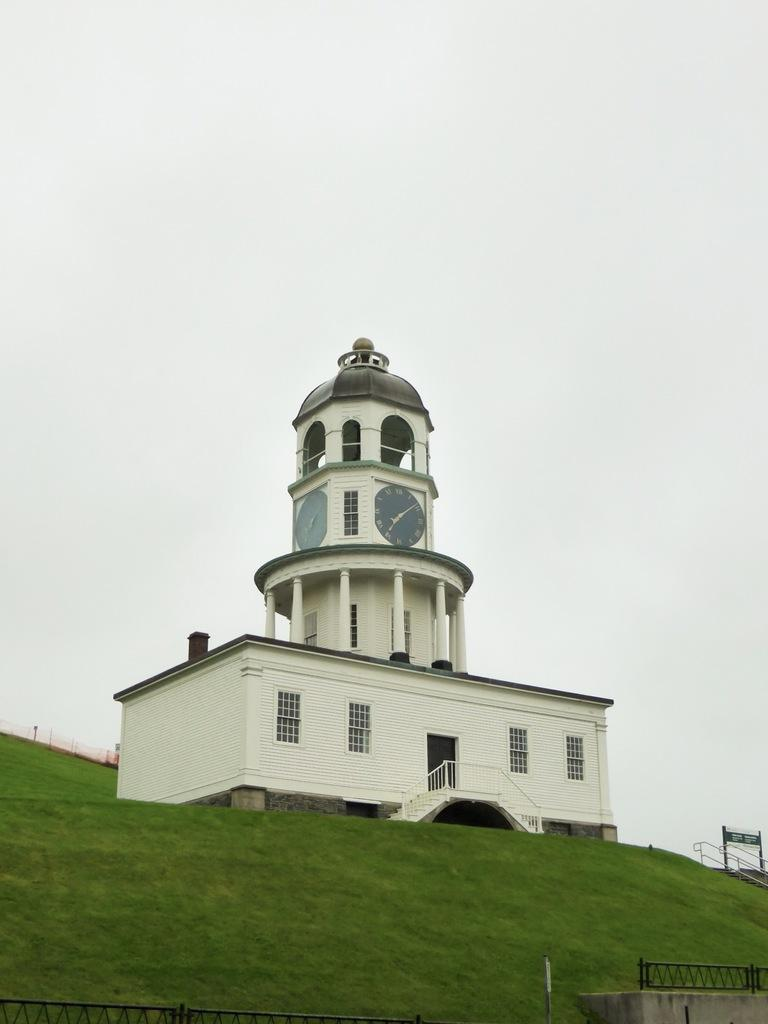What type of structure is in the image? There is a building in the image. What feature can be seen on the building? The building has windows. What time-telling device is present in the building? There is a wall clock in the building. What is located in front of the building? There are grills and grass in front of the building. What can be seen in the background of the image? The sky is visible in the background of the image. What type of oil is being used to lubricate the governor's joints in the image? There is no governor or oil present in the image; it features a building with windows, a wall clock, grills, grass, and a visible sky. 